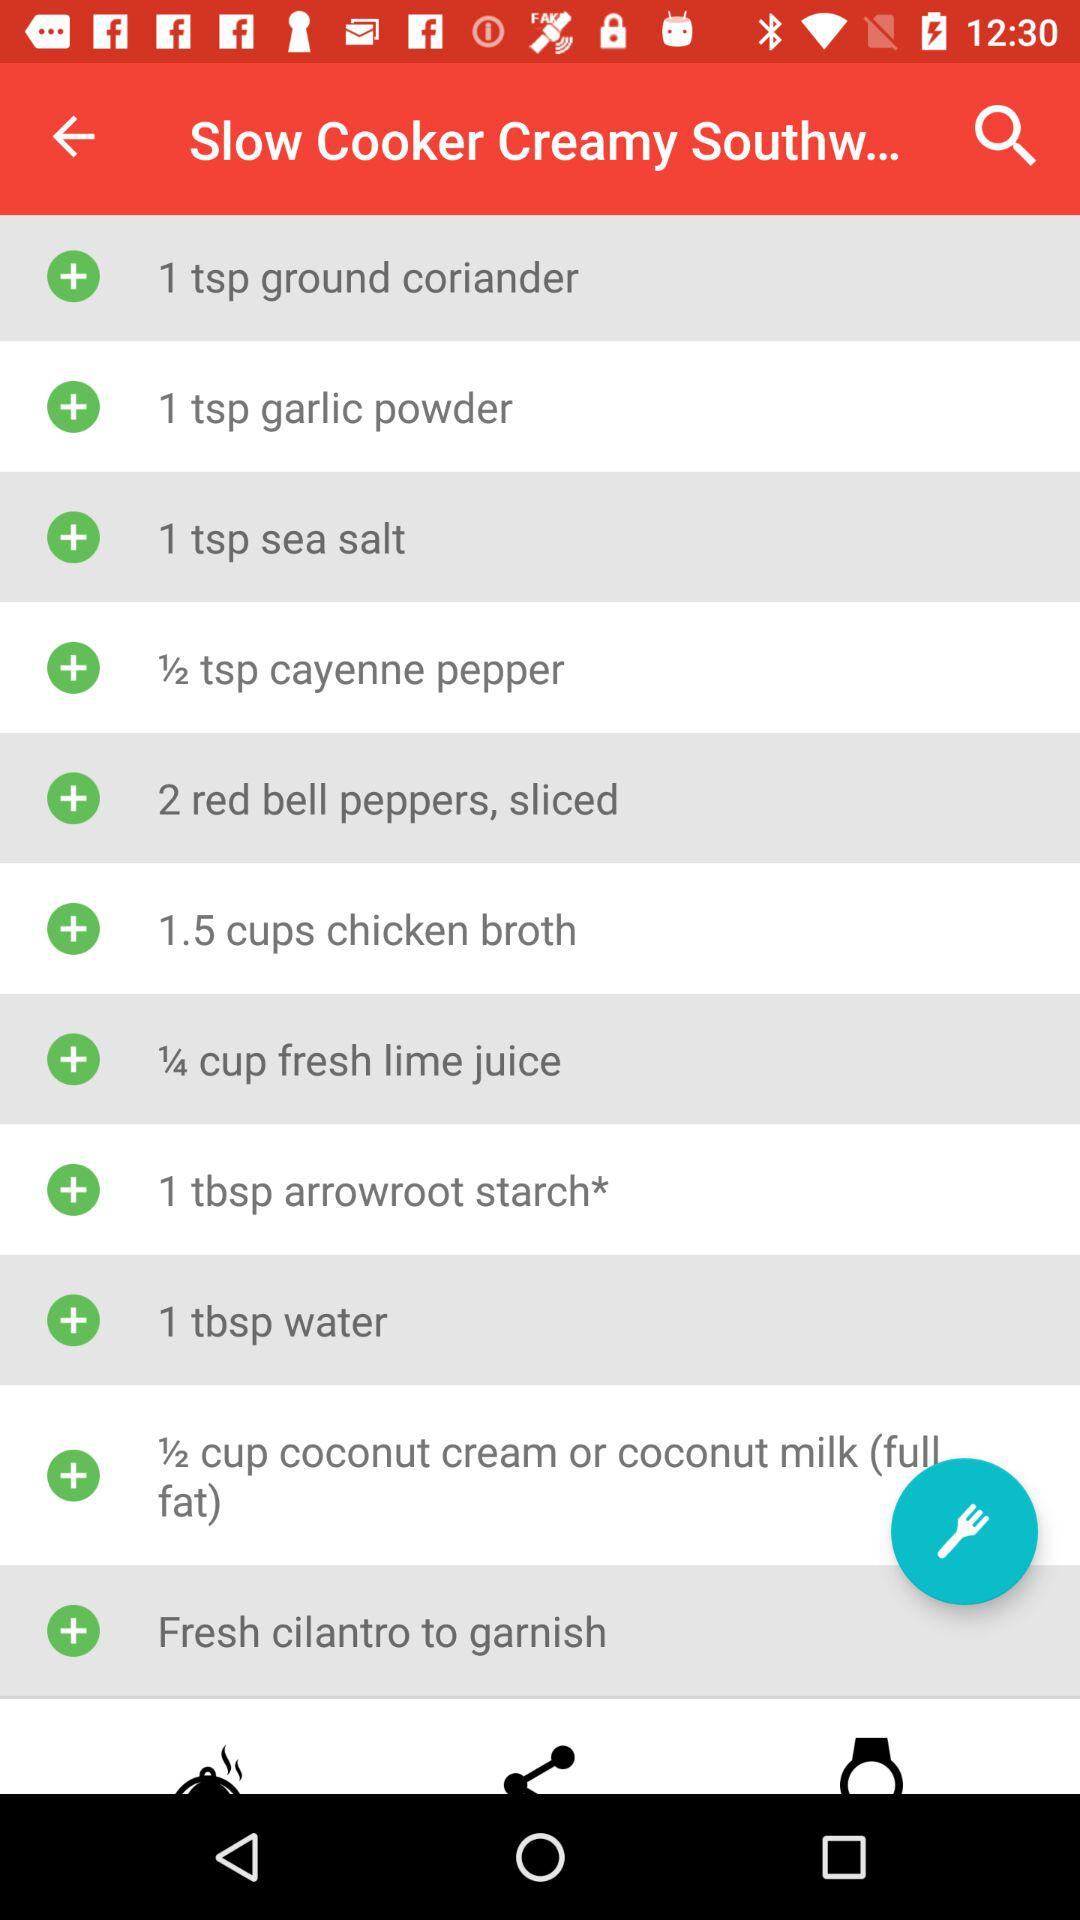How much water is required? The required amount of water is 1 tablespoon. 